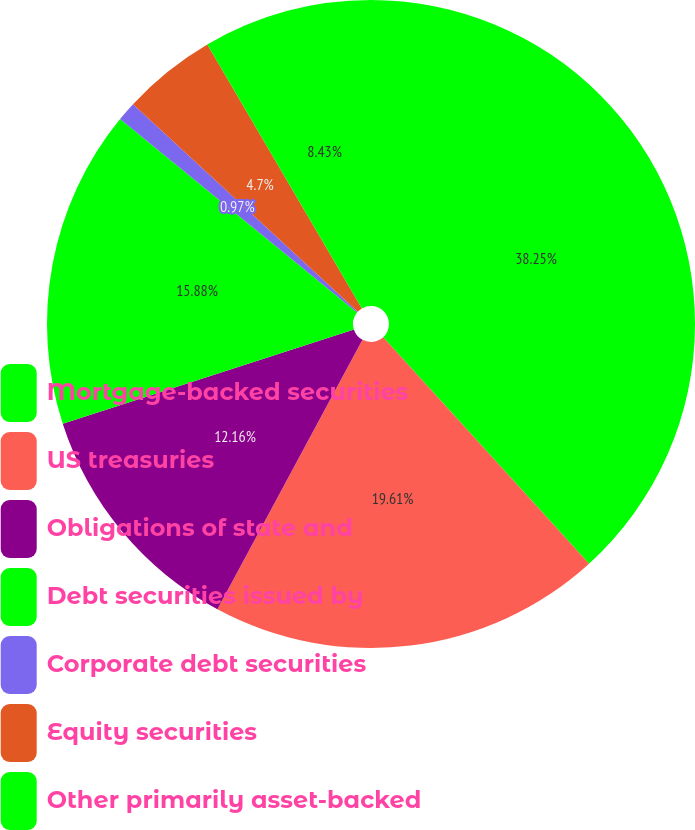Convert chart. <chart><loc_0><loc_0><loc_500><loc_500><pie_chart><fcel>Mortgage-backed securities<fcel>US treasuries<fcel>Obligations of state and<fcel>Debt securities issued by<fcel>Corporate debt securities<fcel>Equity securities<fcel>Other primarily asset-backed<nl><fcel>38.25%<fcel>19.61%<fcel>12.16%<fcel>15.88%<fcel>0.97%<fcel>4.7%<fcel>8.43%<nl></chart> 